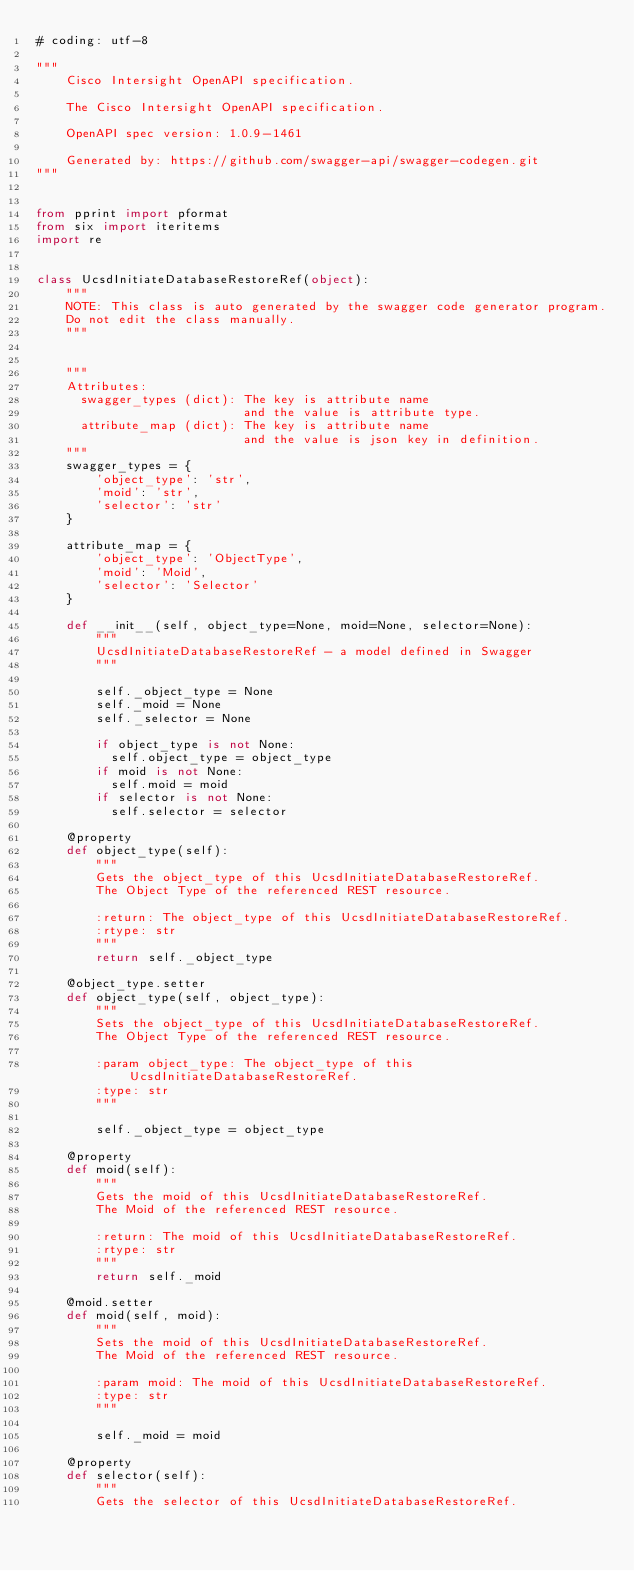Convert code to text. <code><loc_0><loc_0><loc_500><loc_500><_Python_># coding: utf-8

"""
    Cisco Intersight OpenAPI specification.

    The Cisco Intersight OpenAPI specification.

    OpenAPI spec version: 1.0.9-1461
    
    Generated by: https://github.com/swagger-api/swagger-codegen.git
"""


from pprint import pformat
from six import iteritems
import re


class UcsdInitiateDatabaseRestoreRef(object):
    """
    NOTE: This class is auto generated by the swagger code generator program.
    Do not edit the class manually.
    """


    """
    Attributes:
      swagger_types (dict): The key is attribute name
                            and the value is attribute type.
      attribute_map (dict): The key is attribute name
                            and the value is json key in definition.
    """
    swagger_types = {
        'object_type': 'str',
        'moid': 'str',
        'selector': 'str'
    }

    attribute_map = {
        'object_type': 'ObjectType',
        'moid': 'Moid',
        'selector': 'Selector'
    }

    def __init__(self, object_type=None, moid=None, selector=None):
        """
        UcsdInitiateDatabaseRestoreRef - a model defined in Swagger
        """

        self._object_type = None
        self._moid = None
        self._selector = None

        if object_type is not None:
          self.object_type = object_type
        if moid is not None:
          self.moid = moid
        if selector is not None:
          self.selector = selector

    @property
    def object_type(self):
        """
        Gets the object_type of this UcsdInitiateDatabaseRestoreRef.
        The Object Type of the referenced REST resource.

        :return: The object_type of this UcsdInitiateDatabaseRestoreRef.
        :rtype: str
        """
        return self._object_type

    @object_type.setter
    def object_type(self, object_type):
        """
        Sets the object_type of this UcsdInitiateDatabaseRestoreRef.
        The Object Type of the referenced REST resource.

        :param object_type: The object_type of this UcsdInitiateDatabaseRestoreRef.
        :type: str
        """

        self._object_type = object_type

    @property
    def moid(self):
        """
        Gets the moid of this UcsdInitiateDatabaseRestoreRef.
        The Moid of the referenced REST resource.

        :return: The moid of this UcsdInitiateDatabaseRestoreRef.
        :rtype: str
        """
        return self._moid

    @moid.setter
    def moid(self, moid):
        """
        Sets the moid of this UcsdInitiateDatabaseRestoreRef.
        The Moid of the referenced REST resource.

        :param moid: The moid of this UcsdInitiateDatabaseRestoreRef.
        :type: str
        """

        self._moid = moid

    @property
    def selector(self):
        """
        Gets the selector of this UcsdInitiateDatabaseRestoreRef.</code> 